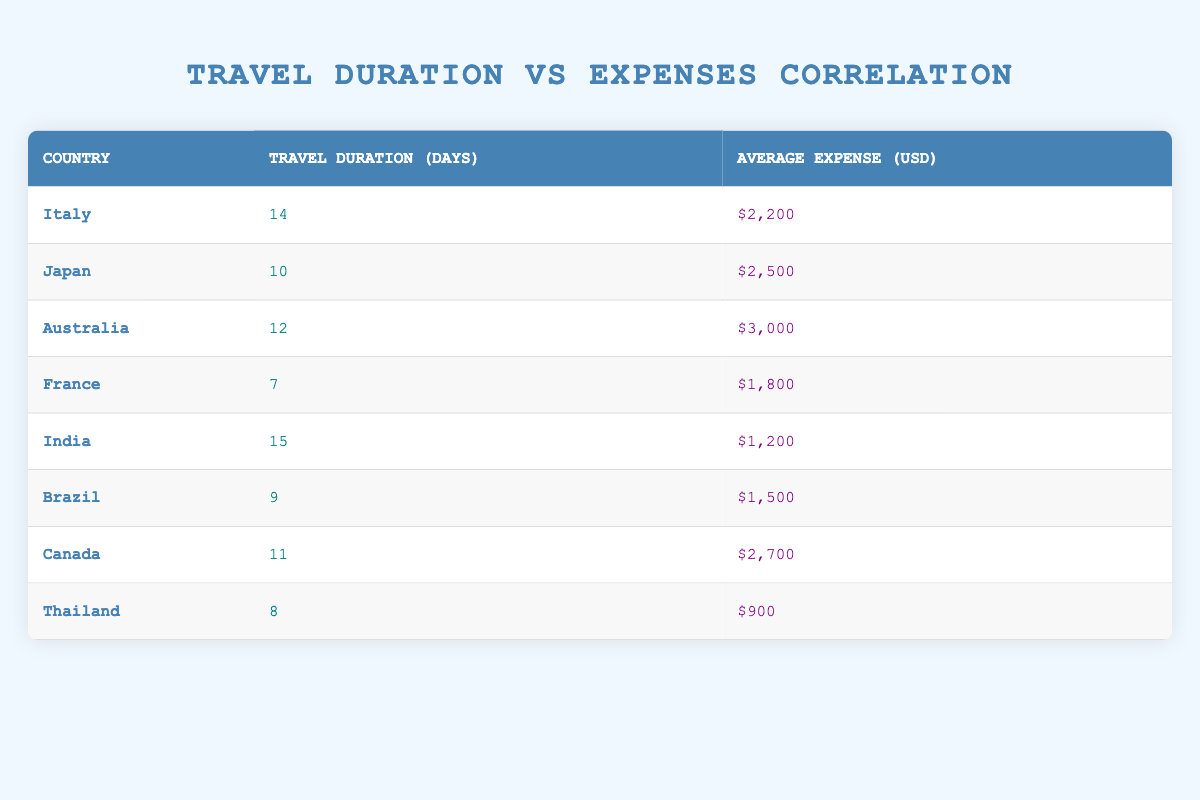What is the travel duration in days for Japan? The table shows that Japan has a travel duration of 10 days under the "Travel Duration (Days)" column.
Answer: 10 days Which country has the highest average expense? Looking through the "Average Expense (USD)" column, Australia has the highest average expense at $3,000.
Answer: Australia What is the sum of travel durations for Italy and India? Italy has a travel duration of 14 days and India has 15 days. Adding these together gives 14 + 15 = 29 days.
Answer: 29 days Is the average expense for Thailand higher than that for Brazil? Thailand's average expense is $900, and Brazil's average expense is $1,500. Since $900 is less than $1,500, the answer is no.
Answer: No What is the average travel duration of all the countries listed in the table? The travel durations are: 14, 10, 12, 7, 15, 9, 11, and 8 days. Summing these (14 + 10 + 12 + 7 + 15 + 9 + 11 + 8) gives 96 days, and there are 8 countries, so the average is 96/8 = 12 days.
Answer: 12 days Which country has the closest average expense to Italy? Italy has an average expense of $2,200. Canada's average expense is $2,700, which is the closest. Japan, with $2,500, is also close but further than Canada.
Answer: Canada How much lower is the average expense in India compared to Australia? India has an average expense of $1,200 and Australia has $3,000. The difference is $3,000 - $1,200 = $1,800, so India's expense is $1,800 lower.
Answer: $1,800 Is the travel duration for France equal to the average travel duration of all countries? The travel duration for France is 7 days. From the previous average calculation, the average duration is 12 days. Since 7 is not equal to 12, the answer is no.
Answer: No 